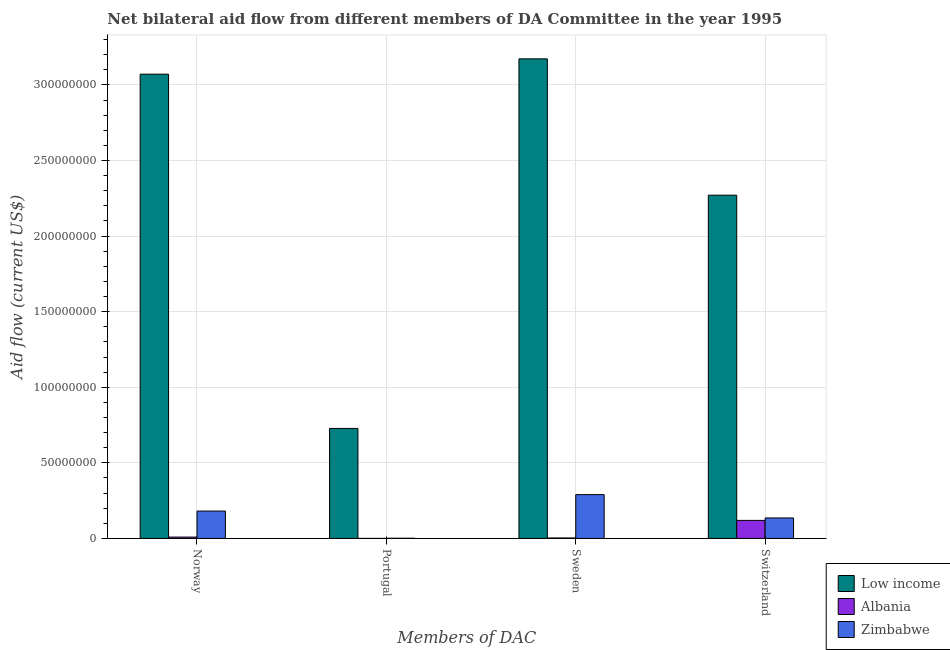How many different coloured bars are there?
Provide a succinct answer. 3. How many groups of bars are there?
Your response must be concise. 4. How many bars are there on the 1st tick from the right?
Give a very brief answer. 3. What is the label of the 2nd group of bars from the left?
Provide a succinct answer. Portugal. What is the amount of aid given by switzerland in Low income?
Make the answer very short. 2.27e+08. Across all countries, what is the maximum amount of aid given by norway?
Keep it short and to the point. 3.07e+08. Across all countries, what is the minimum amount of aid given by switzerland?
Your response must be concise. 1.19e+07. In which country was the amount of aid given by sweden minimum?
Ensure brevity in your answer.  Albania. What is the total amount of aid given by sweden in the graph?
Make the answer very short. 3.47e+08. What is the difference between the amount of aid given by switzerland in Albania and that in Low income?
Your answer should be very brief. -2.15e+08. What is the difference between the amount of aid given by sweden in Low income and the amount of aid given by norway in Albania?
Provide a succinct answer. 3.16e+08. What is the average amount of aid given by portugal per country?
Your answer should be compact. 2.43e+07. What is the difference between the amount of aid given by portugal and amount of aid given by sweden in Low income?
Offer a terse response. -2.44e+08. In how many countries, is the amount of aid given by sweden greater than 180000000 US$?
Keep it short and to the point. 1. What is the ratio of the amount of aid given by sweden in Low income to that in Zimbabwe?
Ensure brevity in your answer.  10.95. Is the difference between the amount of aid given by switzerland in Low income and Albania greater than the difference between the amount of aid given by portugal in Low income and Albania?
Offer a very short reply. Yes. What is the difference between the highest and the second highest amount of aid given by switzerland?
Keep it short and to the point. 2.14e+08. What is the difference between the highest and the lowest amount of aid given by norway?
Ensure brevity in your answer.  3.06e+08. In how many countries, is the amount of aid given by norway greater than the average amount of aid given by norway taken over all countries?
Give a very brief answer. 1. Is it the case that in every country, the sum of the amount of aid given by switzerland and amount of aid given by sweden is greater than the sum of amount of aid given by norway and amount of aid given by portugal?
Provide a succinct answer. No. What does the 2nd bar from the left in Portugal represents?
Give a very brief answer. Albania. What does the 1st bar from the right in Portugal represents?
Your response must be concise. Zimbabwe. How many bars are there?
Make the answer very short. 12. How many countries are there in the graph?
Provide a succinct answer. 3. What is the difference between two consecutive major ticks on the Y-axis?
Offer a very short reply. 5.00e+07. Are the values on the major ticks of Y-axis written in scientific E-notation?
Your response must be concise. No. Does the graph contain any zero values?
Your answer should be compact. No. Does the graph contain grids?
Give a very brief answer. Yes. Where does the legend appear in the graph?
Make the answer very short. Bottom right. How many legend labels are there?
Offer a terse response. 3. What is the title of the graph?
Provide a short and direct response. Net bilateral aid flow from different members of DA Committee in the year 1995. Does "Portugal" appear as one of the legend labels in the graph?
Provide a short and direct response. No. What is the label or title of the X-axis?
Make the answer very short. Members of DAC. What is the Aid flow (current US$) of Low income in Norway?
Give a very brief answer. 3.07e+08. What is the Aid flow (current US$) of Albania in Norway?
Keep it short and to the point. 8.90e+05. What is the Aid flow (current US$) in Zimbabwe in Norway?
Your answer should be very brief. 1.81e+07. What is the Aid flow (current US$) in Low income in Portugal?
Provide a short and direct response. 7.28e+07. What is the Aid flow (current US$) in Albania in Portugal?
Your answer should be very brief. 10000. What is the Aid flow (current US$) in Zimbabwe in Portugal?
Your response must be concise. 1.30e+05. What is the Aid flow (current US$) in Low income in Sweden?
Offer a very short reply. 3.17e+08. What is the Aid flow (current US$) in Zimbabwe in Sweden?
Make the answer very short. 2.90e+07. What is the Aid flow (current US$) in Low income in Switzerland?
Your response must be concise. 2.27e+08. What is the Aid flow (current US$) in Albania in Switzerland?
Give a very brief answer. 1.19e+07. What is the Aid flow (current US$) in Zimbabwe in Switzerland?
Ensure brevity in your answer.  1.36e+07. Across all Members of DAC, what is the maximum Aid flow (current US$) in Low income?
Keep it short and to the point. 3.17e+08. Across all Members of DAC, what is the maximum Aid flow (current US$) in Albania?
Ensure brevity in your answer.  1.19e+07. Across all Members of DAC, what is the maximum Aid flow (current US$) in Zimbabwe?
Offer a terse response. 2.90e+07. Across all Members of DAC, what is the minimum Aid flow (current US$) in Low income?
Keep it short and to the point. 7.28e+07. Across all Members of DAC, what is the minimum Aid flow (current US$) in Zimbabwe?
Offer a terse response. 1.30e+05. What is the total Aid flow (current US$) of Low income in the graph?
Keep it short and to the point. 9.24e+08. What is the total Aid flow (current US$) in Albania in the graph?
Provide a short and direct response. 1.31e+07. What is the total Aid flow (current US$) in Zimbabwe in the graph?
Give a very brief answer. 6.08e+07. What is the difference between the Aid flow (current US$) in Low income in Norway and that in Portugal?
Ensure brevity in your answer.  2.34e+08. What is the difference between the Aid flow (current US$) in Albania in Norway and that in Portugal?
Give a very brief answer. 8.80e+05. What is the difference between the Aid flow (current US$) of Zimbabwe in Norway and that in Portugal?
Give a very brief answer. 1.80e+07. What is the difference between the Aid flow (current US$) of Low income in Norway and that in Sweden?
Give a very brief answer. -1.01e+07. What is the difference between the Aid flow (current US$) of Albania in Norway and that in Sweden?
Make the answer very short. 5.90e+05. What is the difference between the Aid flow (current US$) of Zimbabwe in Norway and that in Sweden?
Offer a terse response. -1.09e+07. What is the difference between the Aid flow (current US$) in Low income in Norway and that in Switzerland?
Your response must be concise. 8.00e+07. What is the difference between the Aid flow (current US$) of Albania in Norway and that in Switzerland?
Ensure brevity in your answer.  -1.10e+07. What is the difference between the Aid flow (current US$) of Zimbabwe in Norway and that in Switzerland?
Offer a terse response. 4.56e+06. What is the difference between the Aid flow (current US$) of Low income in Portugal and that in Sweden?
Provide a short and direct response. -2.44e+08. What is the difference between the Aid flow (current US$) of Albania in Portugal and that in Sweden?
Your answer should be very brief. -2.90e+05. What is the difference between the Aid flow (current US$) in Zimbabwe in Portugal and that in Sweden?
Your answer should be compact. -2.88e+07. What is the difference between the Aid flow (current US$) of Low income in Portugal and that in Switzerland?
Ensure brevity in your answer.  -1.54e+08. What is the difference between the Aid flow (current US$) in Albania in Portugal and that in Switzerland?
Make the answer very short. -1.19e+07. What is the difference between the Aid flow (current US$) of Zimbabwe in Portugal and that in Switzerland?
Offer a terse response. -1.34e+07. What is the difference between the Aid flow (current US$) in Low income in Sweden and that in Switzerland?
Give a very brief answer. 9.02e+07. What is the difference between the Aid flow (current US$) of Albania in Sweden and that in Switzerland?
Provide a short and direct response. -1.16e+07. What is the difference between the Aid flow (current US$) in Zimbabwe in Sweden and that in Switzerland?
Your answer should be very brief. 1.54e+07. What is the difference between the Aid flow (current US$) of Low income in Norway and the Aid flow (current US$) of Albania in Portugal?
Your answer should be compact. 3.07e+08. What is the difference between the Aid flow (current US$) of Low income in Norway and the Aid flow (current US$) of Zimbabwe in Portugal?
Keep it short and to the point. 3.07e+08. What is the difference between the Aid flow (current US$) in Albania in Norway and the Aid flow (current US$) in Zimbabwe in Portugal?
Your response must be concise. 7.60e+05. What is the difference between the Aid flow (current US$) in Low income in Norway and the Aid flow (current US$) in Albania in Sweden?
Your response must be concise. 3.07e+08. What is the difference between the Aid flow (current US$) in Low income in Norway and the Aid flow (current US$) in Zimbabwe in Sweden?
Offer a very short reply. 2.78e+08. What is the difference between the Aid flow (current US$) in Albania in Norway and the Aid flow (current US$) in Zimbabwe in Sweden?
Provide a succinct answer. -2.81e+07. What is the difference between the Aid flow (current US$) in Low income in Norway and the Aid flow (current US$) in Albania in Switzerland?
Your answer should be very brief. 2.95e+08. What is the difference between the Aid flow (current US$) in Low income in Norway and the Aid flow (current US$) in Zimbabwe in Switzerland?
Offer a terse response. 2.94e+08. What is the difference between the Aid flow (current US$) in Albania in Norway and the Aid flow (current US$) in Zimbabwe in Switzerland?
Keep it short and to the point. -1.27e+07. What is the difference between the Aid flow (current US$) in Low income in Portugal and the Aid flow (current US$) in Albania in Sweden?
Ensure brevity in your answer.  7.25e+07. What is the difference between the Aid flow (current US$) in Low income in Portugal and the Aid flow (current US$) in Zimbabwe in Sweden?
Your answer should be very brief. 4.38e+07. What is the difference between the Aid flow (current US$) of Albania in Portugal and the Aid flow (current US$) of Zimbabwe in Sweden?
Give a very brief answer. -2.90e+07. What is the difference between the Aid flow (current US$) in Low income in Portugal and the Aid flow (current US$) in Albania in Switzerland?
Make the answer very short. 6.08e+07. What is the difference between the Aid flow (current US$) in Low income in Portugal and the Aid flow (current US$) in Zimbabwe in Switzerland?
Provide a short and direct response. 5.92e+07. What is the difference between the Aid flow (current US$) in Albania in Portugal and the Aid flow (current US$) in Zimbabwe in Switzerland?
Keep it short and to the point. -1.35e+07. What is the difference between the Aid flow (current US$) in Low income in Sweden and the Aid flow (current US$) in Albania in Switzerland?
Give a very brief answer. 3.05e+08. What is the difference between the Aid flow (current US$) of Low income in Sweden and the Aid flow (current US$) of Zimbabwe in Switzerland?
Your response must be concise. 3.04e+08. What is the difference between the Aid flow (current US$) of Albania in Sweden and the Aid flow (current US$) of Zimbabwe in Switzerland?
Your answer should be very brief. -1.32e+07. What is the average Aid flow (current US$) in Low income per Members of DAC?
Give a very brief answer. 2.31e+08. What is the average Aid flow (current US$) in Albania per Members of DAC?
Keep it short and to the point. 3.28e+06. What is the average Aid flow (current US$) of Zimbabwe per Members of DAC?
Keep it short and to the point. 1.52e+07. What is the difference between the Aid flow (current US$) in Low income and Aid flow (current US$) in Albania in Norway?
Keep it short and to the point. 3.06e+08. What is the difference between the Aid flow (current US$) of Low income and Aid flow (current US$) of Zimbabwe in Norway?
Your response must be concise. 2.89e+08. What is the difference between the Aid flow (current US$) of Albania and Aid flow (current US$) of Zimbabwe in Norway?
Give a very brief answer. -1.72e+07. What is the difference between the Aid flow (current US$) in Low income and Aid flow (current US$) in Albania in Portugal?
Provide a short and direct response. 7.28e+07. What is the difference between the Aid flow (current US$) in Low income and Aid flow (current US$) in Zimbabwe in Portugal?
Your answer should be very brief. 7.26e+07. What is the difference between the Aid flow (current US$) of Low income and Aid flow (current US$) of Albania in Sweden?
Your answer should be very brief. 3.17e+08. What is the difference between the Aid flow (current US$) in Low income and Aid flow (current US$) in Zimbabwe in Sweden?
Make the answer very short. 2.88e+08. What is the difference between the Aid flow (current US$) in Albania and Aid flow (current US$) in Zimbabwe in Sweden?
Provide a short and direct response. -2.87e+07. What is the difference between the Aid flow (current US$) of Low income and Aid flow (current US$) of Albania in Switzerland?
Keep it short and to the point. 2.15e+08. What is the difference between the Aid flow (current US$) of Low income and Aid flow (current US$) of Zimbabwe in Switzerland?
Provide a short and direct response. 2.14e+08. What is the difference between the Aid flow (current US$) of Albania and Aid flow (current US$) of Zimbabwe in Switzerland?
Your answer should be very brief. -1.62e+06. What is the ratio of the Aid flow (current US$) of Low income in Norway to that in Portugal?
Give a very brief answer. 4.22. What is the ratio of the Aid flow (current US$) of Albania in Norway to that in Portugal?
Make the answer very short. 89. What is the ratio of the Aid flow (current US$) in Zimbabwe in Norway to that in Portugal?
Provide a short and direct response. 139.31. What is the ratio of the Aid flow (current US$) of Low income in Norway to that in Sweden?
Your answer should be very brief. 0.97. What is the ratio of the Aid flow (current US$) of Albania in Norway to that in Sweden?
Keep it short and to the point. 2.97. What is the ratio of the Aid flow (current US$) of Zimbabwe in Norway to that in Sweden?
Offer a terse response. 0.62. What is the ratio of the Aid flow (current US$) of Low income in Norway to that in Switzerland?
Ensure brevity in your answer.  1.35. What is the ratio of the Aid flow (current US$) of Albania in Norway to that in Switzerland?
Your answer should be very brief. 0.07. What is the ratio of the Aid flow (current US$) of Zimbabwe in Norway to that in Switzerland?
Keep it short and to the point. 1.34. What is the ratio of the Aid flow (current US$) in Low income in Portugal to that in Sweden?
Offer a very short reply. 0.23. What is the ratio of the Aid flow (current US$) of Zimbabwe in Portugal to that in Sweden?
Offer a terse response. 0. What is the ratio of the Aid flow (current US$) in Low income in Portugal to that in Switzerland?
Provide a succinct answer. 0.32. What is the ratio of the Aid flow (current US$) of Albania in Portugal to that in Switzerland?
Offer a terse response. 0. What is the ratio of the Aid flow (current US$) in Zimbabwe in Portugal to that in Switzerland?
Provide a short and direct response. 0.01. What is the ratio of the Aid flow (current US$) of Low income in Sweden to that in Switzerland?
Provide a succinct answer. 1.4. What is the ratio of the Aid flow (current US$) in Albania in Sweden to that in Switzerland?
Your answer should be very brief. 0.03. What is the ratio of the Aid flow (current US$) of Zimbabwe in Sweden to that in Switzerland?
Offer a terse response. 2.14. What is the difference between the highest and the second highest Aid flow (current US$) of Low income?
Your response must be concise. 1.01e+07. What is the difference between the highest and the second highest Aid flow (current US$) in Albania?
Offer a terse response. 1.10e+07. What is the difference between the highest and the second highest Aid flow (current US$) in Zimbabwe?
Make the answer very short. 1.09e+07. What is the difference between the highest and the lowest Aid flow (current US$) in Low income?
Your answer should be compact. 2.44e+08. What is the difference between the highest and the lowest Aid flow (current US$) of Albania?
Your response must be concise. 1.19e+07. What is the difference between the highest and the lowest Aid flow (current US$) of Zimbabwe?
Provide a succinct answer. 2.88e+07. 